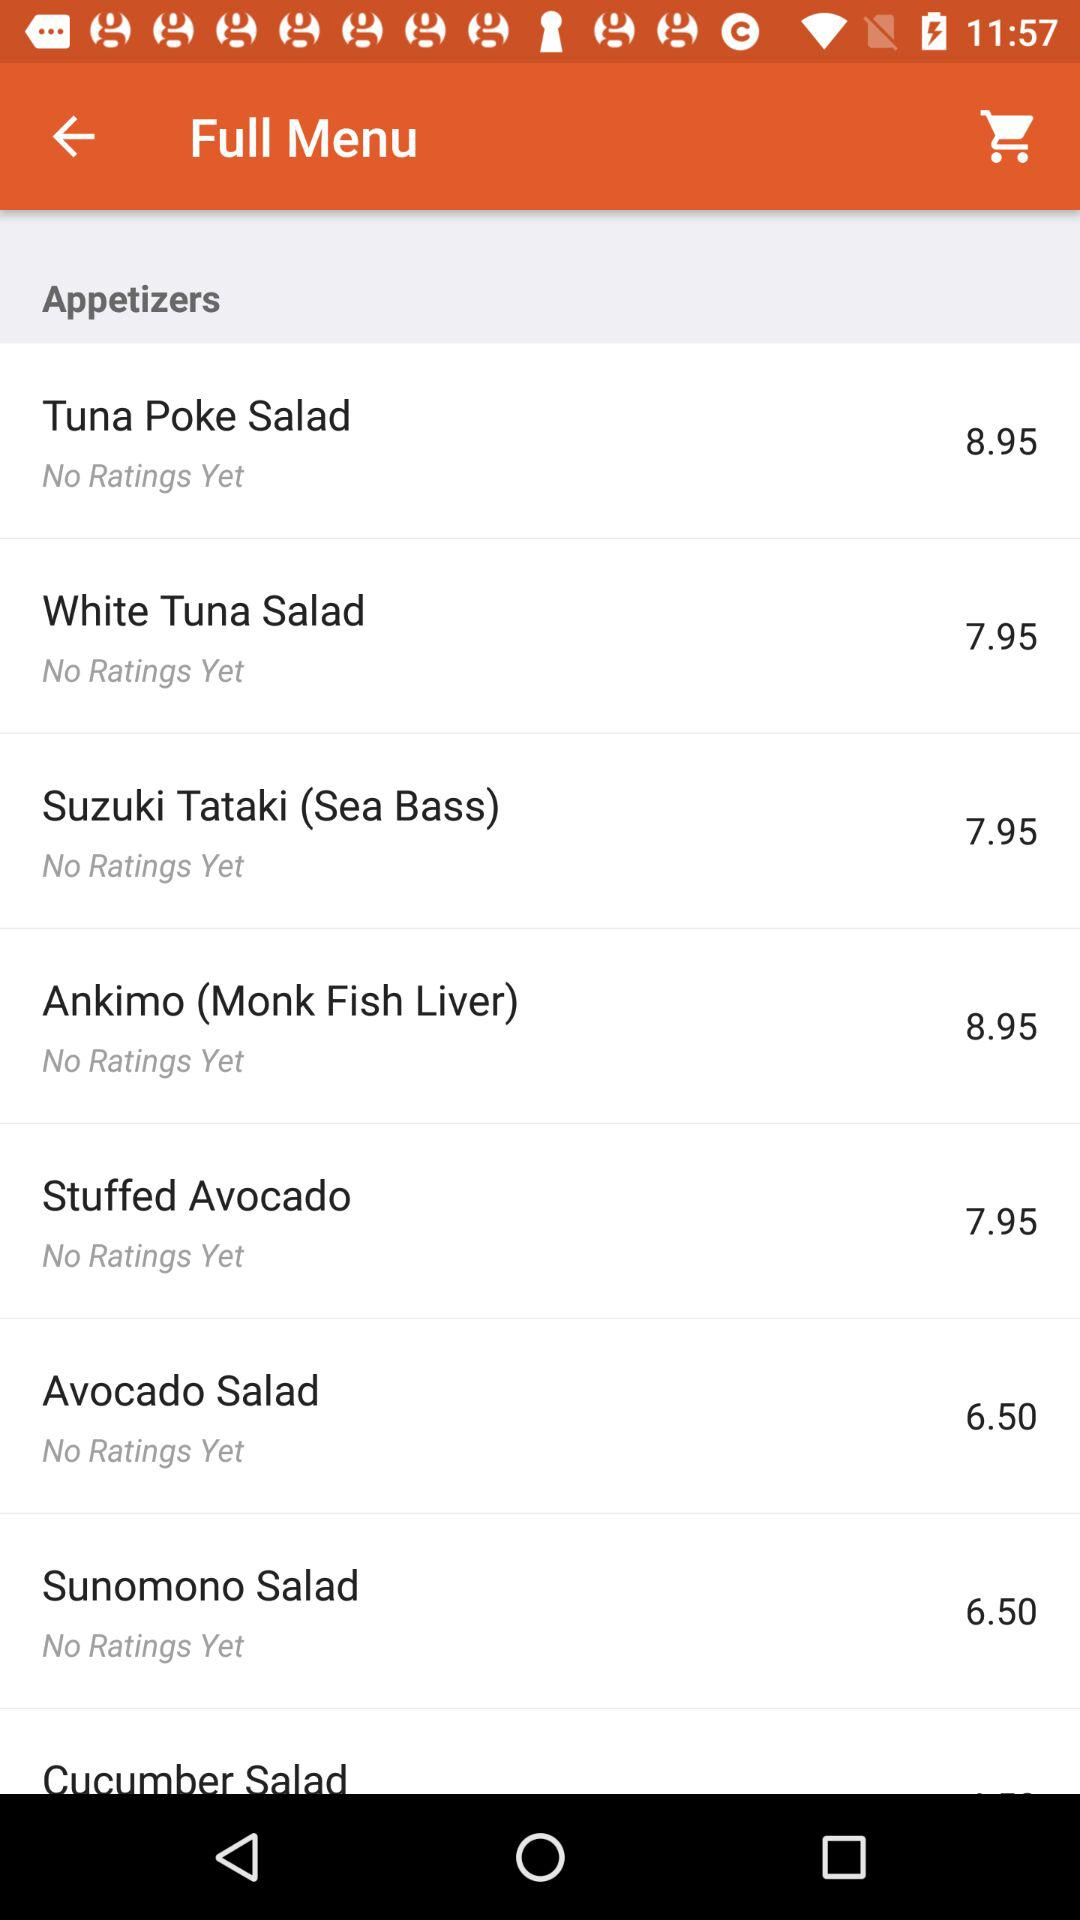What is the price of the stuffed avocado? The price of the stuffed avocado is 7.95. 